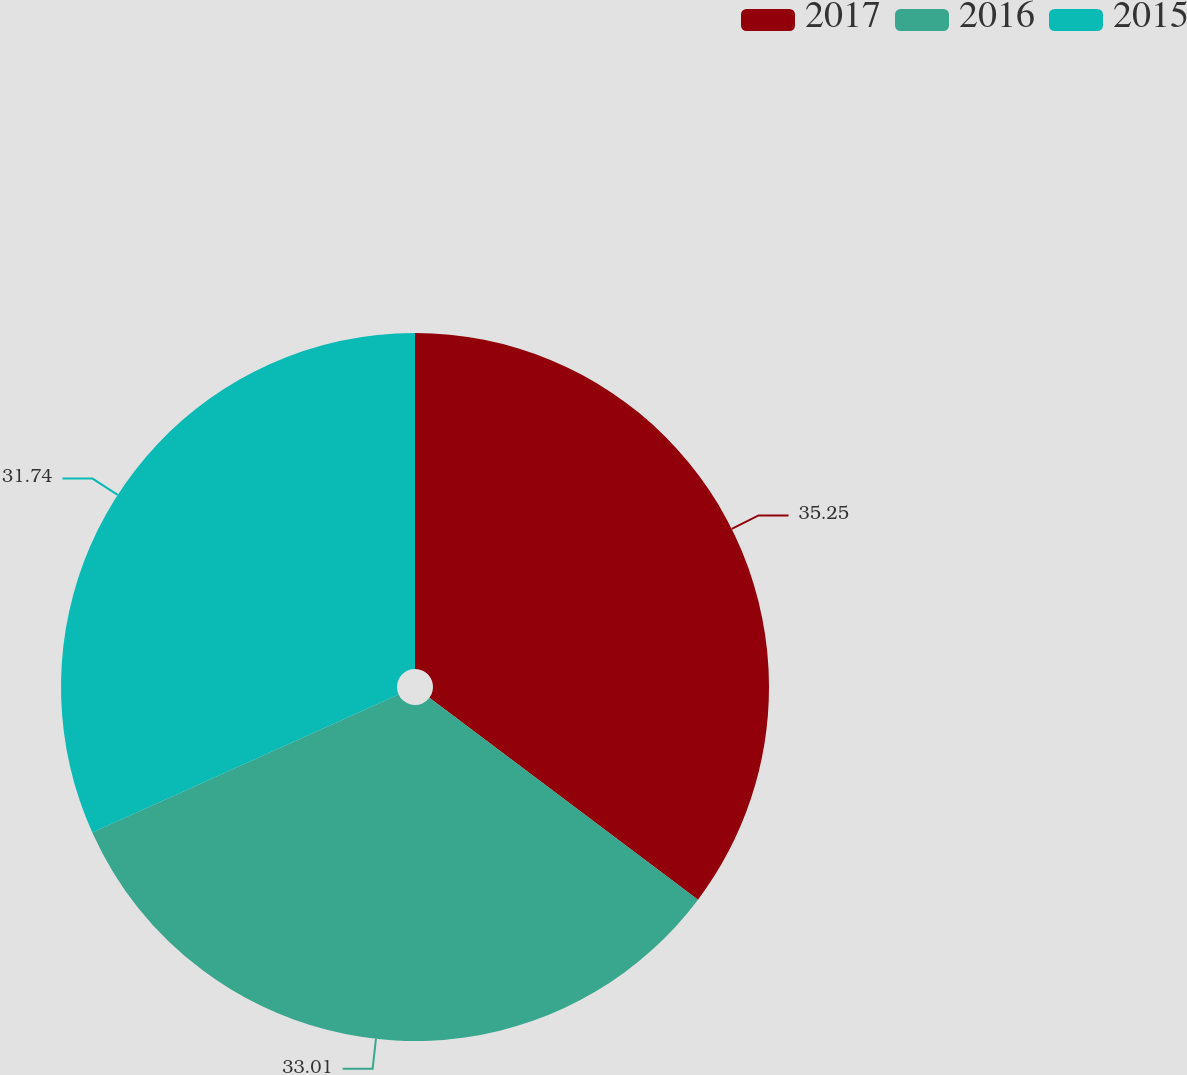Convert chart. <chart><loc_0><loc_0><loc_500><loc_500><pie_chart><fcel>2017<fcel>2016<fcel>2015<nl><fcel>35.26%<fcel>33.01%<fcel>31.74%<nl></chart> 